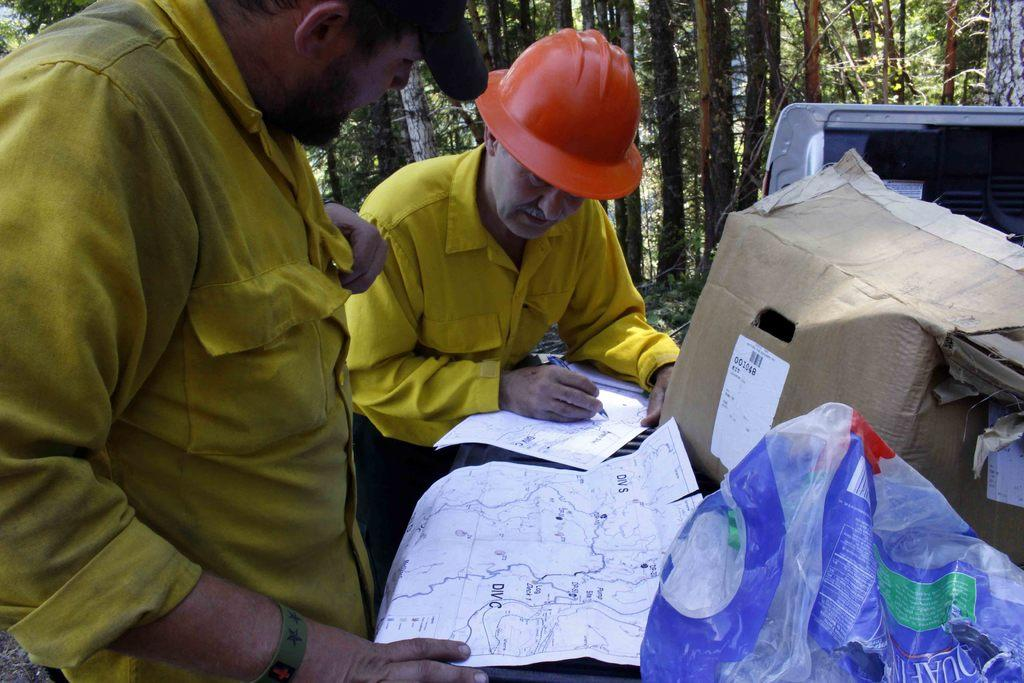How many people are in the image? There are two people in the image. What is one person holding in the image? One person is holding a pen. What is on the paper in the image? The information about the objects in the image is not provided, so we cannot determine what is on the paper. What can be seen in the background of the image? There is a vehicle and trees in the background of the image. What type of underwear is the person wearing in the image? There is no information about the person's clothing, including underwear, in the image. Can you tell me how many baskets are visible in the image? There is no mention of baskets in the image, so we cannot determine if any are present. 